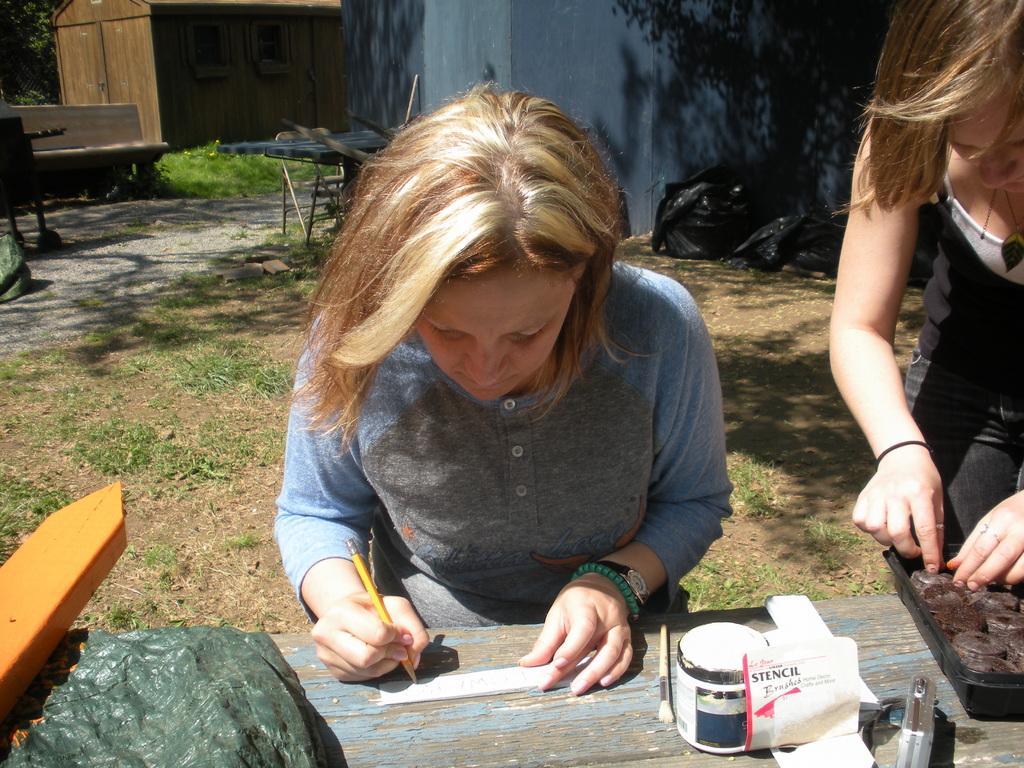How would you summarize this image in a sentence or two? In this picture there is a girl in the center of the image, she is writing and there is another girl on the right side of the image, there is a house at the top side of the image. 